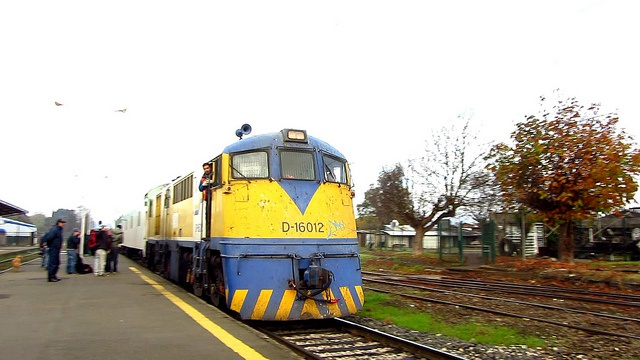Describe the objects in this image and their specific colors. I can see train in white, black, gray, and gold tones, people in white, black, gray, navy, and darkblue tones, people in white, black, darkgray, and gray tones, people in white, black, gray, and darkgray tones, and people in white, black, navy, blue, and gray tones in this image. 